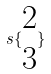Convert formula to latex. <formula><loc_0><loc_0><loc_500><loc_500>s \{ \begin{matrix} 2 \\ 3 \end{matrix} \}</formula> 